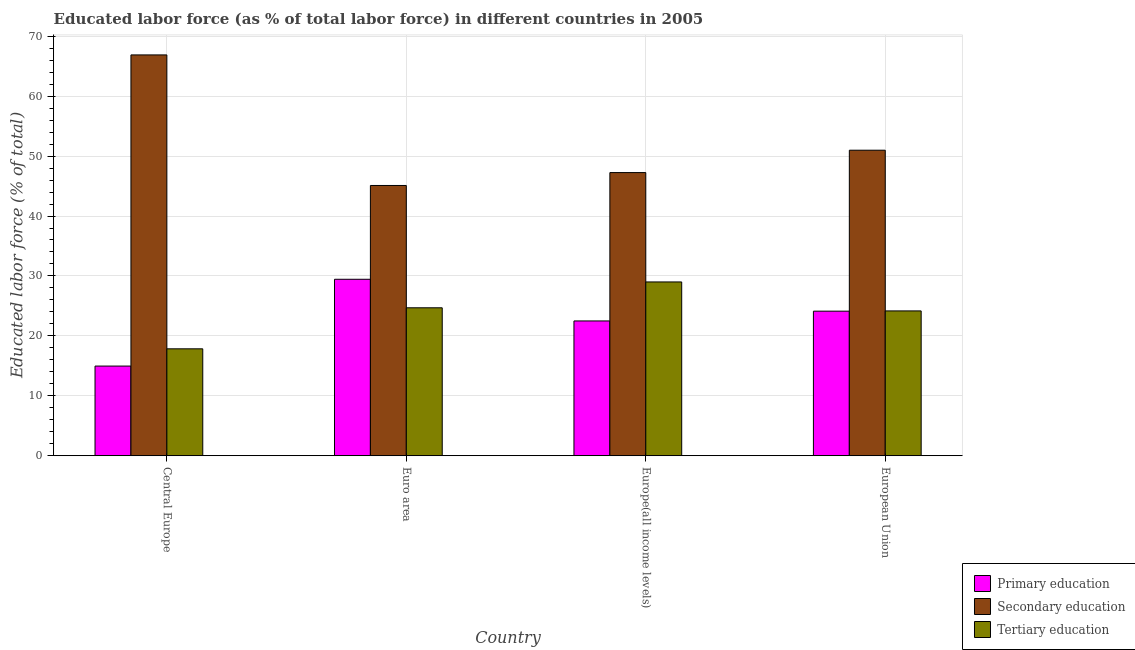Are the number of bars per tick equal to the number of legend labels?
Offer a terse response. Yes. Are the number of bars on each tick of the X-axis equal?
Make the answer very short. Yes. What is the label of the 2nd group of bars from the left?
Your response must be concise. Euro area. What is the percentage of labor force who received tertiary education in Europe(all income levels)?
Your answer should be very brief. 29. Across all countries, what is the maximum percentage of labor force who received primary education?
Your answer should be very brief. 29.44. Across all countries, what is the minimum percentage of labor force who received tertiary education?
Offer a very short reply. 17.84. In which country was the percentage of labor force who received tertiary education maximum?
Provide a short and direct response. Europe(all income levels). In which country was the percentage of labor force who received secondary education minimum?
Your answer should be compact. Euro area. What is the total percentage of labor force who received primary education in the graph?
Your response must be concise. 91.02. What is the difference between the percentage of labor force who received primary education in Europe(all income levels) and that in European Union?
Provide a short and direct response. -1.63. What is the difference between the percentage of labor force who received secondary education in Euro area and the percentage of labor force who received primary education in Central Europe?
Offer a terse response. 30.14. What is the average percentage of labor force who received tertiary education per country?
Make the answer very short. 23.92. What is the difference between the percentage of labor force who received secondary education and percentage of labor force who received primary education in Euro area?
Keep it short and to the point. 15.65. In how many countries, is the percentage of labor force who received secondary education greater than 26 %?
Ensure brevity in your answer.  4. What is the ratio of the percentage of labor force who received primary education in Central Europe to that in European Union?
Offer a terse response. 0.62. Is the percentage of labor force who received secondary education in Central Europe less than that in Europe(all income levels)?
Provide a succinct answer. No. What is the difference between the highest and the second highest percentage of labor force who received tertiary education?
Offer a very short reply. 4.31. What is the difference between the highest and the lowest percentage of labor force who received tertiary education?
Offer a very short reply. 11.16. Is the sum of the percentage of labor force who received secondary education in Central Europe and Europe(all income levels) greater than the maximum percentage of labor force who received primary education across all countries?
Offer a terse response. Yes. What does the 3rd bar from the left in European Union represents?
Offer a terse response. Tertiary education. What does the 3rd bar from the right in Euro area represents?
Provide a succinct answer. Primary education. Are the values on the major ticks of Y-axis written in scientific E-notation?
Your answer should be very brief. No. Does the graph contain any zero values?
Your response must be concise. No. Does the graph contain grids?
Make the answer very short. Yes. Where does the legend appear in the graph?
Make the answer very short. Bottom right. How many legend labels are there?
Make the answer very short. 3. How are the legend labels stacked?
Make the answer very short. Vertical. What is the title of the graph?
Your answer should be very brief. Educated labor force (as % of total labor force) in different countries in 2005. Does "Natural gas sources" appear as one of the legend labels in the graph?
Offer a terse response. No. What is the label or title of the Y-axis?
Keep it short and to the point. Educated labor force (% of total). What is the Educated labor force (% of total) in Primary education in Central Europe?
Make the answer very short. 14.96. What is the Educated labor force (% of total) of Secondary education in Central Europe?
Offer a very short reply. 66.88. What is the Educated labor force (% of total) of Tertiary education in Central Europe?
Your answer should be compact. 17.84. What is the Educated labor force (% of total) of Primary education in Euro area?
Your response must be concise. 29.44. What is the Educated labor force (% of total) in Secondary education in Euro area?
Offer a terse response. 45.1. What is the Educated labor force (% of total) in Tertiary education in Euro area?
Make the answer very short. 24.68. What is the Educated labor force (% of total) in Primary education in Europe(all income levels)?
Your response must be concise. 22.49. What is the Educated labor force (% of total) in Secondary education in Europe(all income levels)?
Keep it short and to the point. 47.25. What is the Educated labor force (% of total) of Tertiary education in Europe(all income levels)?
Offer a terse response. 29. What is the Educated labor force (% of total) of Primary education in European Union?
Your answer should be very brief. 24.12. What is the Educated labor force (% of total) of Secondary education in European Union?
Offer a very short reply. 50.98. What is the Educated labor force (% of total) in Tertiary education in European Union?
Ensure brevity in your answer.  24.16. Across all countries, what is the maximum Educated labor force (% of total) of Primary education?
Keep it short and to the point. 29.44. Across all countries, what is the maximum Educated labor force (% of total) of Secondary education?
Provide a succinct answer. 66.88. Across all countries, what is the maximum Educated labor force (% of total) in Tertiary education?
Ensure brevity in your answer.  29. Across all countries, what is the minimum Educated labor force (% of total) in Primary education?
Make the answer very short. 14.96. Across all countries, what is the minimum Educated labor force (% of total) in Secondary education?
Provide a succinct answer. 45.1. Across all countries, what is the minimum Educated labor force (% of total) in Tertiary education?
Provide a short and direct response. 17.84. What is the total Educated labor force (% of total) of Primary education in the graph?
Make the answer very short. 91.02. What is the total Educated labor force (% of total) of Secondary education in the graph?
Ensure brevity in your answer.  210.21. What is the total Educated labor force (% of total) in Tertiary education in the graph?
Offer a terse response. 95.69. What is the difference between the Educated labor force (% of total) in Primary education in Central Europe and that in Euro area?
Ensure brevity in your answer.  -14.48. What is the difference between the Educated labor force (% of total) in Secondary education in Central Europe and that in Euro area?
Offer a terse response. 21.79. What is the difference between the Educated labor force (% of total) in Tertiary education in Central Europe and that in Euro area?
Keep it short and to the point. -6.85. What is the difference between the Educated labor force (% of total) of Primary education in Central Europe and that in Europe(all income levels)?
Provide a succinct answer. -7.53. What is the difference between the Educated labor force (% of total) of Secondary education in Central Europe and that in Europe(all income levels)?
Your answer should be very brief. 19.63. What is the difference between the Educated labor force (% of total) in Tertiary education in Central Europe and that in Europe(all income levels)?
Give a very brief answer. -11.16. What is the difference between the Educated labor force (% of total) of Primary education in Central Europe and that in European Union?
Offer a terse response. -9.16. What is the difference between the Educated labor force (% of total) in Secondary education in Central Europe and that in European Union?
Make the answer very short. 15.9. What is the difference between the Educated labor force (% of total) of Tertiary education in Central Europe and that in European Union?
Your answer should be compact. -6.33. What is the difference between the Educated labor force (% of total) of Primary education in Euro area and that in Europe(all income levels)?
Give a very brief answer. 6.95. What is the difference between the Educated labor force (% of total) of Secondary education in Euro area and that in Europe(all income levels)?
Your answer should be compact. -2.15. What is the difference between the Educated labor force (% of total) of Tertiary education in Euro area and that in Europe(all income levels)?
Your response must be concise. -4.31. What is the difference between the Educated labor force (% of total) in Primary education in Euro area and that in European Union?
Offer a very short reply. 5.32. What is the difference between the Educated labor force (% of total) in Secondary education in Euro area and that in European Union?
Offer a terse response. -5.89. What is the difference between the Educated labor force (% of total) of Tertiary education in Euro area and that in European Union?
Ensure brevity in your answer.  0.52. What is the difference between the Educated labor force (% of total) of Primary education in Europe(all income levels) and that in European Union?
Provide a short and direct response. -1.63. What is the difference between the Educated labor force (% of total) of Secondary education in Europe(all income levels) and that in European Union?
Give a very brief answer. -3.73. What is the difference between the Educated labor force (% of total) of Tertiary education in Europe(all income levels) and that in European Union?
Offer a very short reply. 4.83. What is the difference between the Educated labor force (% of total) of Primary education in Central Europe and the Educated labor force (% of total) of Secondary education in Euro area?
Give a very brief answer. -30.14. What is the difference between the Educated labor force (% of total) of Primary education in Central Europe and the Educated labor force (% of total) of Tertiary education in Euro area?
Make the answer very short. -9.72. What is the difference between the Educated labor force (% of total) in Secondary education in Central Europe and the Educated labor force (% of total) in Tertiary education in Euro area?
Give a very brief answer. 42.2. What is the difference between the Educated labor force (% of total) of Primary education in Central Europe and the Educated labor force (% of total) of Secondary education in Europe(all income levels)?
Provide a short and direct response. -32.29. What is the difference between the Educated labor force (% of total) of Primary education in Central Europe and the Educated labor force (% of total) of Tertiary education in Europe(all income levels)?
Provide a succinct answer. -14.04. What is the difference between the Educated labor force (% of total) in Secondary education in Central Europe and the Educated labor force (% of total) in Tertiary education in Europe(all income levels)?
Give a very brief answer. 37.88. What is the difference between the Educated labor force (% of total) in Primary education in Central Europe and the Educated labor force (% of total) in Secondary education in European Union?
Make the answer very short. -36.02. What is the difference between the Educated labor force (% of total) in Primary education in Central Europe and the Educated labor force (% of total) in Tertiary education in European Union?
Ensure brevity in your answer.  -9.2. What is the difference between the Educated labor force (% of total) of Secondary education in Central Europe and the Educated labor force (% of total) of Tertiary education in European Union?
Provide a succinct answer. 42.72. What is the difference between the Educated labor force (% of total) in Primary education in Euro area and the Educated labor force (% of total) in Secondary education in Europe(all income levels)?
Your answer should be compact. -17.8. What is the difference between the Educated labor force (% of total) in Primary education in Euro area and the Educated labor force (% of total) in Tertiary education in Europe(all income levels)?
Your response must be concise. 0.45. What is the difference between the Educated labor force (% of total) in Secondary education in Euro area and the Educated labor force (% of total) in Tertiary education in Europe(all income levels)?
Offer a very short reply. 16.1. What is the difference between the Educated labor force (% of total) of Primary education in Euro area and the Educated labor force (% of total) of Secondary education in European Union?
Your response must be concise. -21.54. What is the difference between the Educated labor force (% of total) in Primary education in Euro area and the Educated labor force (% of total) in Tertiary education in European Union?
Offer a terse response. 5.28. What is the difference between the Educated labor force (% of total) of Secondary education in Euro area and the Educated labor force (% of total) of Tertiary education in European Union?
Give a very brief answer. 20.93. What is the difference between the Educated labor force (% of total) of Primary education in Europe(all income levels) and the Educated labor force (% of total) of Secondary education in European Union?
Ensure brevity in your answer.  -28.49. What is the difference between the Educated labor force (% of total) in Primary education in Europe(all income levels) and the Educated labor force (% of total) in Tertiary education in European Union?
Provide a succinct answer. -1.67. What is the difference between the Educated labor force (% of total) of Secondary education in Europe(all income levels) and the Educated labor force (% of total) of Tertiary education in European Union?
Keep it short and to the point. 23.08. What is the average Educated labor force (% of total) in Primary education per country?
Your answer should be very brief. 22.75. What is the average Educated labor force (% of total) of Secondary education per country?
Provide a short and direct response. 52.55. What is the average Educated labor force (% of total) of Tertiary education per country?
Make the answer very short. 23.92. What is the difference between the Educated labor force (% of total) in Primary education and Educated labor force (% of total) in Secondary education in Central Europe?
Keep it short and to the point. -51.92. What is the difference between the Educated labor force (% of total) in Primary education and Educated labor force (% of total) in Tertiary education in Central Europe?
Your answer should be compact. -2.88. What is the difference between the Educated labor force (% of total) of Secondary education and Educated labor force (% of total) of Tertiary education in Central Europe?
Your answer should be very brief. 49.04. What is the difference between the Educated labor force (% of total) of Primary education and Educated labor force (% of total) of Secondary education in Euro area?
Your answer should be very brief. -15.65. What is the difference between the Educated labor force (% of total) in Primary education and Educated labor force (% of total) in Tertiary education in Euro area?
Give a very brief answer. 4.76. What is the difference between the Educated labor force (% of total) in Secondary education and Educated labor force (% of total) in Tertiary education in Euro area?
Provide a short and direct response. 20.41. What is the difference between the Educated labor force (% of total) in Primary education and Educated labor force (% of total) in Secondary education in Europe(all income levels)?
Your response must be concise. -24.76. What is the difference between the Educated labor force (% of total) in Primary education and Educated labor force (% of total) in Tertiary education in Europe(all income levels)?
Keep it short and to the point. -6.51. What is the difference between the Educated labor force (% of total) of Secondary education and Educated labor force (% of total) of Tertiary education in Europe(all income levels)?
Provide a succinct answer. 18.25. What is the difference between the Educated labor force (% of total) of Primary education and Educated labor force (% of total) of Secondary education in European Union?
Offer a very short reply. -26.86. What is the difference between the Educated labor force (% of total) of Primary education and Educated labor force (% of total) of Tertiary education in European Union?
Your response must be concise. -0.04. What is the difference between the Educated labor force (% of total) in Secondary education and Educated labor force (% of total) in Tertiary education in European Union?
Offer a very short reply. 26.82. What is the ratio of the Educated labor force (% of total) of Primary education in Central Europe to that in Euro area?
Provide a succinct answer. 0.51. What is the ratio of the Educated labor force (% of total) in Secondary education in Central Europe to that in Euro area?
Your answer should be very brief. 1.48. What is the ratio of the Educated labor force (% of total) of Tertiary education in Central Europe to that in Euro area?
Offer a very short reply. 0.72. What is the ratio of the Educated labor force (% of total) of Primary education in Central Europe to that in Europe(all income levels)?
Provide a succinct answer. 0.67. What is the ratio of the Educated labor force (% of total) of Secondary education in Central Europe to that in Europe(all income levels)?
Make the answer very short. 1.42. What is the ratio of the Educated labor force (% of total) in Tertiary education in Central Europe to that in Europe(all income levels)?
Provide a succinct answer. 0.62. What is the ratio of the Educated labor force (% of total) of Primary education in Central Europe to that in European Union?
Provide a succinct answer. 0.62. What is the ratio of the Educated labor force (% of total) in Secondary education in Central Europe to that in European Union?
Your response must be concise. 1.31. What is the ratio of the Educated labor force (% of total) in Tertiary education in Central Europe to that in European Union?
Ensure brevity in your answer.  0.74. What is the ratio of the Educated labor force (% of total) in Primary education in Euro area to that in Europe(all income levels)?
Your answer should be compact. 1.31. What is the ratio of the Educated labor force (% of total) of Secondary education in Euro area to that in Europe(all income levels)?
Your answer should be very brief. 0.95. What is the ratio of the Educated labor force (% of total) in Tertiary education in Euro area to that in Europe(all income levels)?
Provide a succinct answer. 0.85. What is the ratio of the Educated labor force (% of total) in Primary education in Euro area to that in European Union?
Give a very brief answer. 1.22. What is the ratio of the Educated labor force (% of total) in Secondary education in Euro area to that in European Union?
Provide a succinct answer. 0.88. What is the ratio of the Educated labor force (% of total) of Tertiary education in Euro area to that in European Union?
Offer a terse response. 1.02. What is the ratio of the Educated labor force (% of total) of Primary education in Europe(all income levels) to that in European Union?
Provide a succinct answer. 0.93. What is the ratio of the Educated labor force (% of total) of Secondary education in Europe(all income levels) to that in European Union?
Give a very brief answer. 0.93. What is the ratio of the Educated labor force (% of total) of Tertiary education in Europe(all income levels) to that in European Union?
Provide a short and direct response. 1.2. What is the difference between the highest and the second highest Educated labor force (% of total) of Primary education?
Your answer should be compact. 5.32. What is the difference between the highest and the second highest Educated labor force (% of total) of Secondary education?
Offer a terse response. 15.9. What is the difference between the highest and the second highest Educated labor force (% of total) in Tertiary education?
Give a very brief answer. 4.31. What is the difference between the highest and the lowest Educated labor force (% of total) of Primary education?
Keep it short and to the point. 14.48. What is the difference between the highest and the lowest Educated labor force (% of total) in Secondary education?
Offer a very short reply. 21.79. What is the difference between the highest and the lowest Educated labor force (% of total) in Tertiary education?
Ensure brevity in your answer.  11.16. 